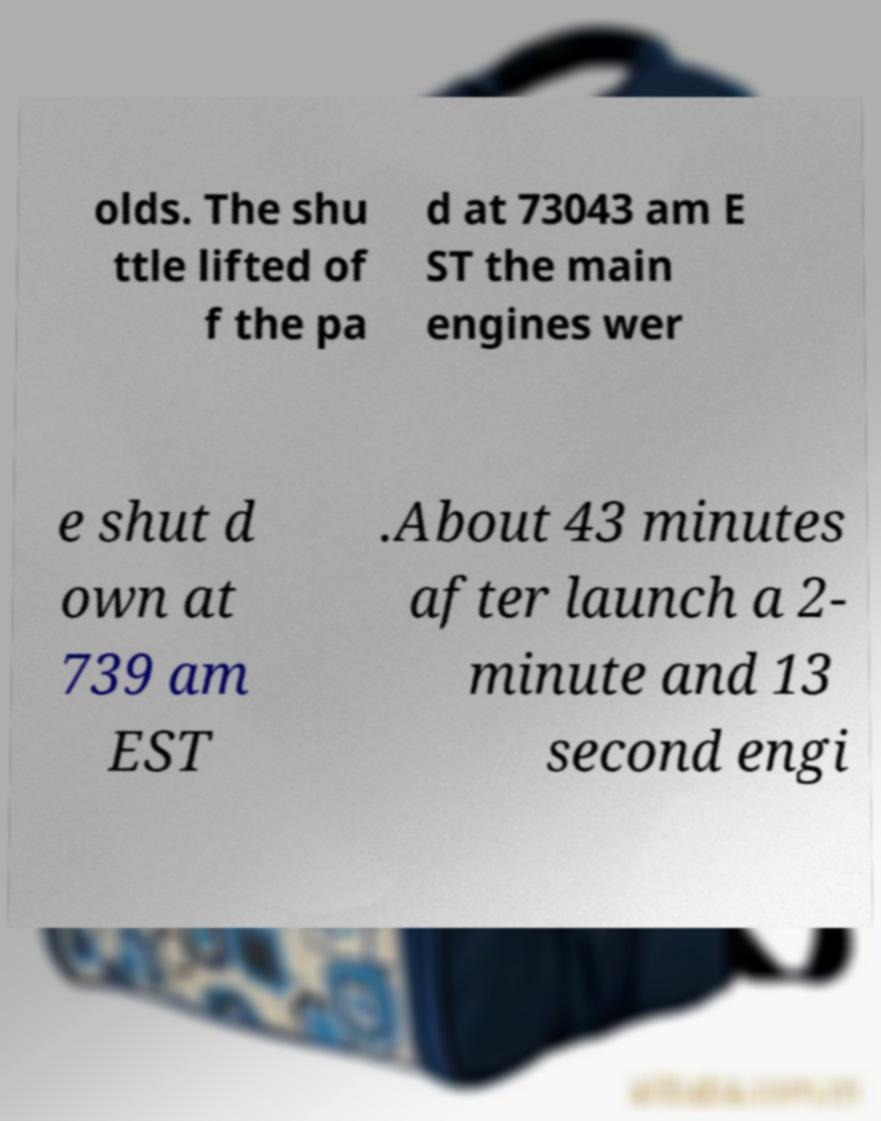I need the written content from this picture converted into text. Can you do that? olds. The shu ttle lifted of f the pa d at 73043 am E ST the main engines wer e shut d own at 739 am EST .About 43 minutes after launch a 2- minute and 13 second engi 